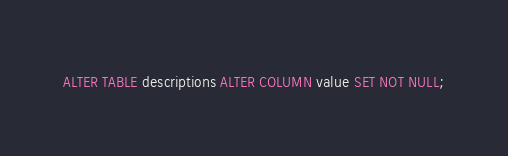Convert code to text. <code><loc_0><loc_0><loc_500><loc_500><_SQL_>ALTER TABLE descriptions ALTER COLUMN value SET NOT NULL;
</code> 